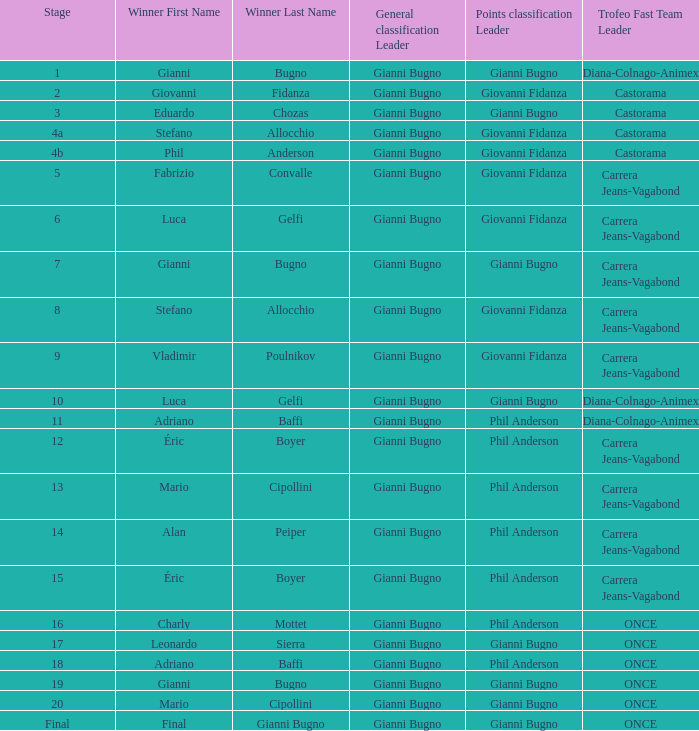Which team holds the fastest record in stage 10 of the trofeo? Diana-Colnago-Animex. 